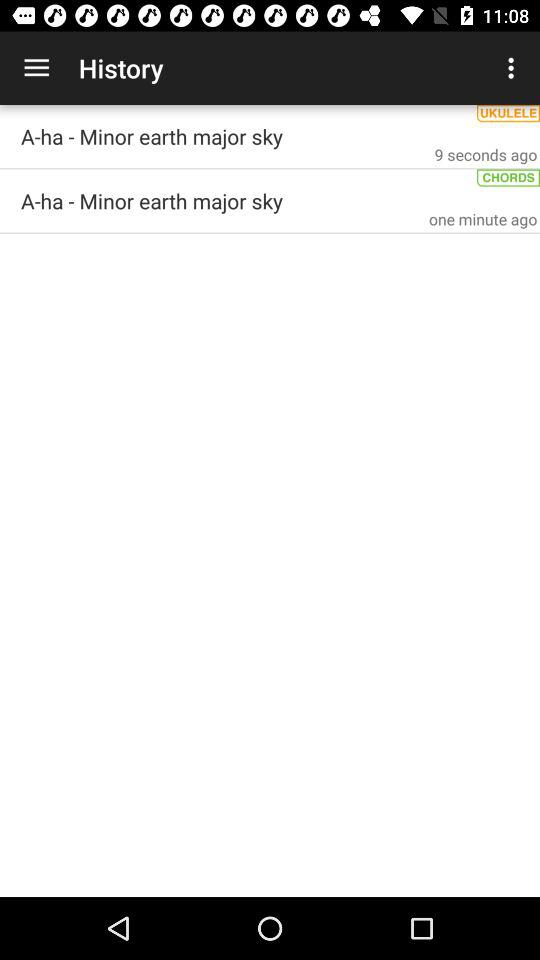What was updated one minute ago? The item that was updated one minute ago was "A-ha - Minor earth major sky". 